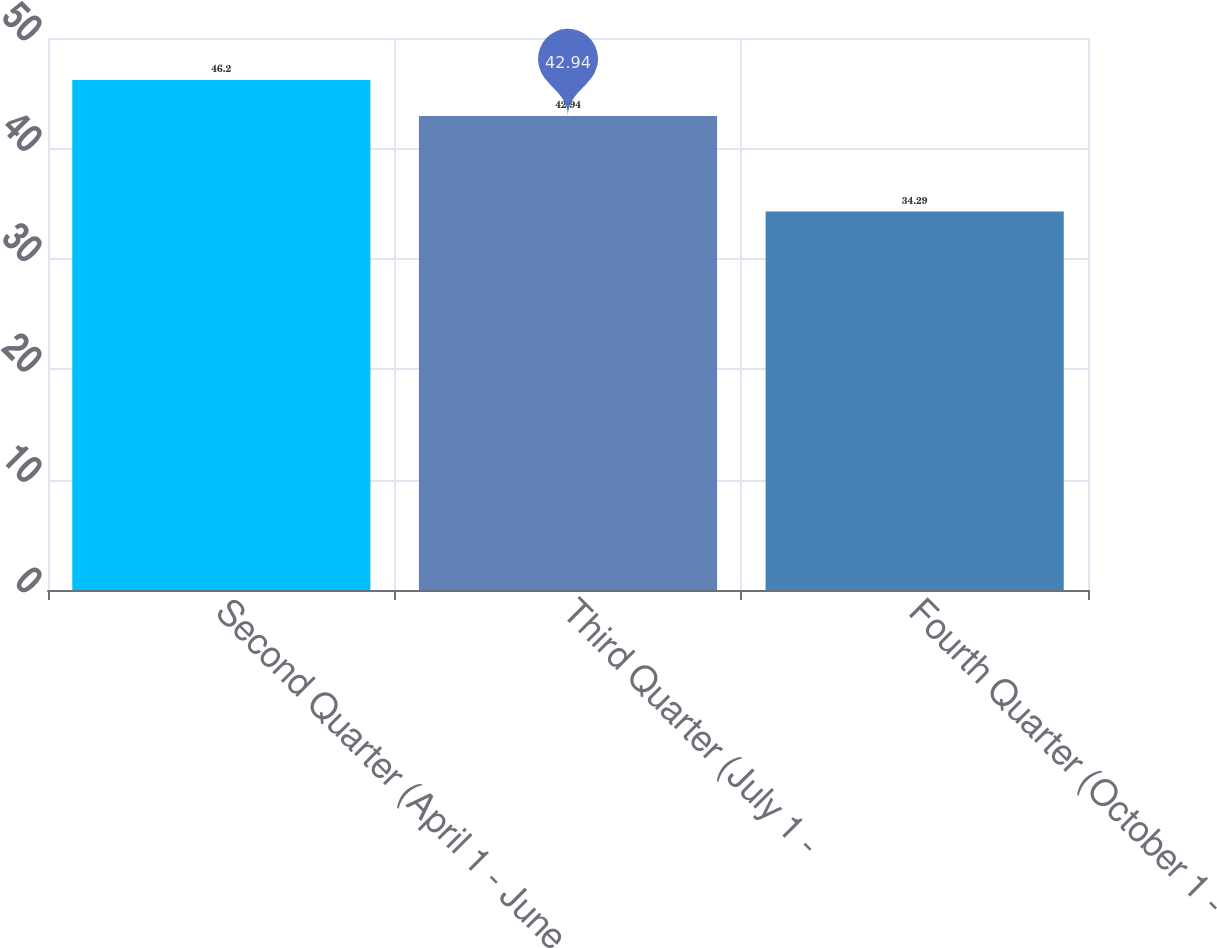<chart> <loc_0><loc_0><loc_500><loc_500><bar_chart><fcel>Second Quarter (April 1 - June<fcel>Third Quarter (July 1 -<fcel>Fourth Quarter (October 1 -<nl><fcel>46.2<fcel>42.94<fcel>34.29<nl></chart> 